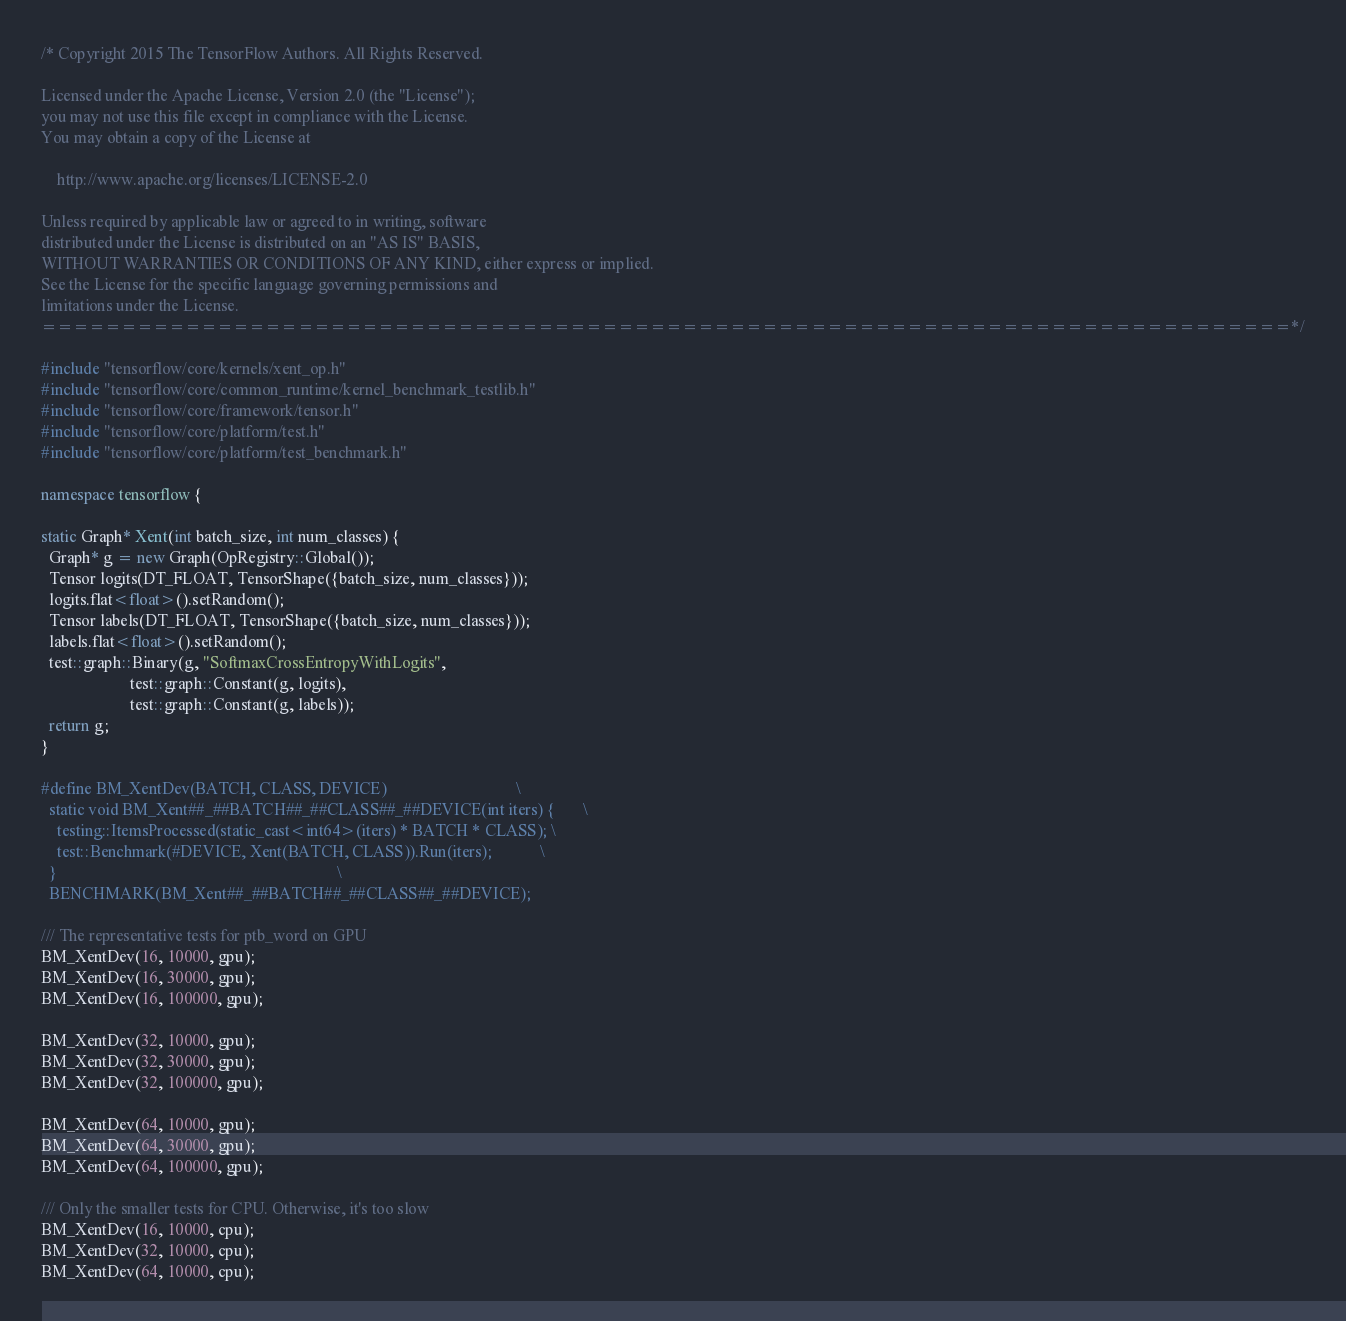<code> <loc_0><loc_0><loc_500><loc_500><_C++_>/* Copyright 2015 The TensorFlow Authors. All Rights Reserved.

Licensed under the Apache License, Version 2.0 (the "License");
you may not use this file except in compliance with the License.
You may obtain a copy of the License at

    http://www.apache.org/licenses/LICENSE-2.0

Unless required by applicable law or agreed to in writing, software
distributed under the License is distributed on an "AS IS" BASIS,
WITHOUT WARRANTIES OR CONDITIONS OF ANY KIND, either express or implied.
See the License for the specific language governing permissions and
limitations under the License.
==============================================================================*/

#include "tensorflow/core/kernels/xent_op.h"
#include "tensorflow/core/common_runtime/kernel_benchmark_testlib.h"
#include "tensorflow/core/framework/tensor.h"
#include "tensorflow/core/platform/test.h"
#include "tensorflow/core/platform/test_benchmark.h"

namespace tensorflow {

static Graph* Xent(int batch_size, int num_classes) {
  Graph* g = new Graph(OpRegistry::Global());
  Tensor logits(DT_FLOAT, TensorShape({batch_size, num_classes}));
  logits.flat<float>().setRandom();
  Tensor labels(DT_FLOAT, TensorShape({batch_size, num_classes}));
  labels.flat<float>().setRandom();
  test::graph::Binary(g, "SoftmaxCrossEntropyWithLogits",
                      test::graph::Constant(g, logits),
                      test::graph::Constant(g, labels));
  return g;
}

#define BM_XentDev(BATCH, CLASS, DEVICE)                                \
  static void BM_Xent##_##BATCH##_##CLASS##_##DEVICE(int iters) {       \
    testing::ItemsProcessed(static_cast<int64>(iters) * BATCH * CLASS); \
    test::Benchmark(#DEVICE, Xent(BATCH, CLASS)).Run(iters);            \
  }                                                                     \
  BENCHMARK(BM_Xent##_##BATCH##_##CLASS##_##DEVICE);

/// The representative tests for ptb_word on GPU
BM_XentDev(16, 10000, gpu);
BM_XentDev(16, 30000, gpu);
BM_XentDev(16, 100000, gpu);

BM_XentDev(32, 10000, gpu);
BM_XentDev(32, 30000, gpu);
BM_XentDev(32, 100000, gpu);

BM_XentDev(64, 10000, gpu);
BM_XentDev(64, 30000, gpu);
BM_XentDev(64, 100000, gpu);

/// Only the smaller tests for CPU. Otherwise, it's too slow
BM_XentDev(16, 10000, cpu);
BM_XentDev(32, 10000, cpu);
BM_XentDev(64, 10000, cpu);</code> 